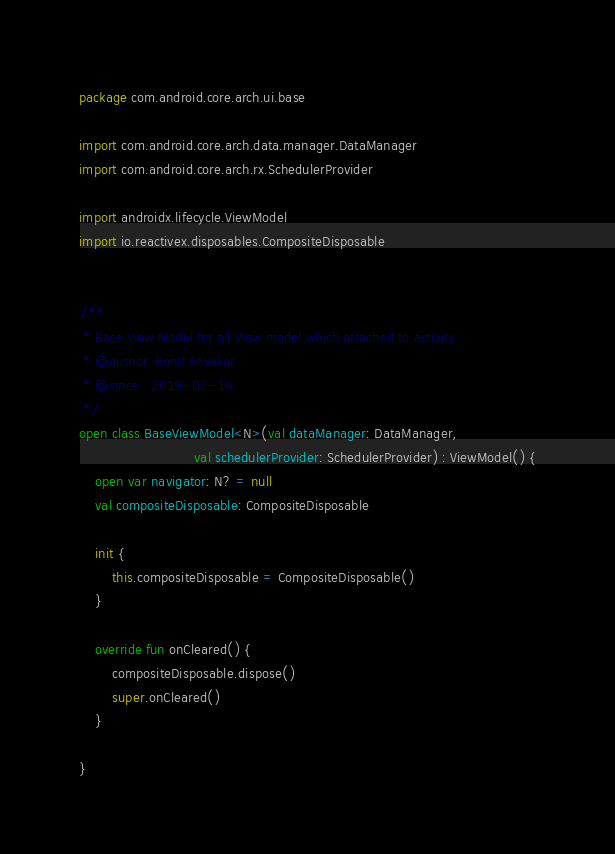<code> <loc_0><loc_0><loc_500><loc_500><_Kotlin_>package com.android.core.arch.ui.base

import com.android.core.arch.data.manager.DataManager
import com.android.core.arch.rx.SchedulerProvider

import androidx.lifecycle.ViewModel
import io.reactivex.disposables.CompositeDisposable


/**
 * Base View Model for all View model which attached to activity
 * @author  Rohit Anvekar
 * @since   2019-02-14
 */
open class BaseViewModel<N>(val dataManager: DataManager,
                            val schedulerProvider: SchedulerProvider) : ViewModel() {
    open var navigator: N? = null
    val compositeDisposable: CompositeDisposable

    init {
        this.compositeDisposable = CompositeDisposable()
    }

    override fun onCleared() {
        compositeDisposable.dispose()
        super.onCleared()
    }

}


</code> 